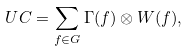<formula> <loc_0><loc_0><loc_500><loc_500>\ U C = \sum _ { f \in G } \Gamma ( f ) \otimes W ( f ) ,</formula> 